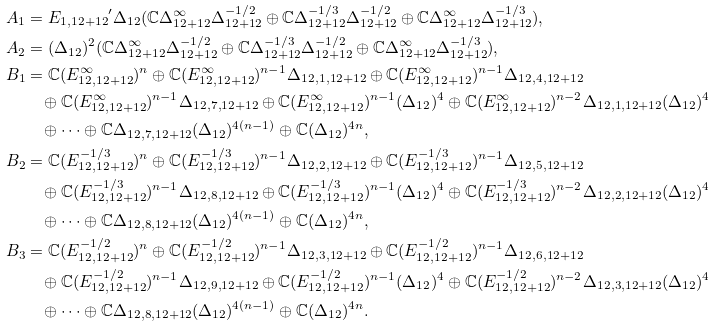<formula> <loc_0><loc_0><loc_500><loc_500>A _ { 1 } & = { E _ { 1 , 1 2 + 1 2 } } ^ { \prime } \Delta _ { 1 2 } ( \mathbb { C } \Delta _ { 1 2 + 1 2 } ^ { \infty } \Delta _ { 1 2 + 1 2 } ^ { - 1 / 2 } \oplus \mathbb { C } \Delta _ { 1 2 + 1 2 } ^ { - 1 / 3 } \Delta _ { 1 2 + 1 2 } ^ { - 1 / 2 } \oplus \mathbb { C } \Delta _ { 1 2 + 1 2 } ^ { \infty } \Delta _ { 1 2 + 1 2 } ^ { - 1 / 3 } ) , \\ A _ { 2 } & = ( \Delta _ { 1 2 } ) ^ { 2 } ( \mathbb { C } \Delta _ { 1 2 + 1 2 } ^ { \infty } \Delta _ { 1 2 + 1 2 } ^ { - 1 / 2 } \oplus \mathbb { C } \Delta _ { 1 2 + 1 2 } ^ { - 1 / 3 } \Delta _ { 1 2 + 1 2 } ^ { - 1 / 2 } \oplus \mathbb { C } \Delta _ { 1 2 + 1 2 } ^ { \infty } \Delta _ { 1 2 + 1 2 } ^ { - 1 / 3 } ) , \\ B _ { 1 } & = \mathbb { C } ( E _ { 1 2 , 1 2 + 1 2 } ^ { \infty } ) ^ { n } \oplus \mathbb { C } ( E _ { 1 2 , 1 2 + 1 2 } ^ { \infty } ) ^ { n - 1 } \Delta _ { 1 2 , 1 , 1 2 + 1 2 } \oplus \mathbb { C } ( E _ { 1 2 , 1 2 + 1 2 } ^ { \infty } ) ^ { n - 1 } \Delta _ { 1 2 , 4 , 1 2 + 1 2 } \\ & \quad \oplus \mathbb { C } ( E _ { 1 2 , 1 2 + 1 2 } ^ { \infty } ) ^ { n - 1 } \Delta _ { 1 2 , 7 , 1 2 + 1 2 } \oplus \mathbb { C } ( E _ { 1 2 , 1 2 + 1 2 } ^ { \infty } ) ^ { n - 1 } ( \Delta _ { 1 2 } ) ^ { 4 } \oplus \mathbb { C } ( E _ { 1 2 , 1 2 + 1 2 } ^ { \infty } ) ^ { n - 2 } \Delta _ { 1 2 , 1 , 1 2 + 1 2 } ( \Delta _ { 1 2 } ) ^ { 4 } \\ & \quad \oplus \cdots \oplus \mathbb { C } \Delta _ { 1 2 , 7 , 1 2 + 1 2 } ( \Delta _ { 1 2 } ) ^ { 4 ( n - 1 ) } \oplus \mathbb { C } ( \Delta _ { 1 2 } ) ^ { 4 n } , \\ B _ { 2 } & = \mathbb { C } ( E _ { 1 2 , 1 2 + 1 2 } ^ { - 1 / 3 } ) ^ { n } \oplus \mathbb { C } ( E _ { 1 2 , 1 2 + 1 2 } ^ { - 1 / 3 } ) ^ { n - 1 } \Delta _ { 1 2 , 2 , 1 2 + 1 2 } \oplus \mathbb { C } ( E _ { 1 2 , 1 2 + 1 2 } ^ { - 1 / 3 } ) ^ { n - 1 } \Delta _ { 1 2 , 5 , 1 2 + 1 2 } \\ & \quad \oplus \mathbb { C } ( E _ { 1 2 , 1 2 + 1 2 } ^ { - 1 / 3 } ) ^ { n - 1 } \Delta _ { 1 2 , 8 , 1 2 + 1 2 } \oplus \mathbb { C } ( E _ { 1 2 , 1 2 + 1 2 } ^ { - 1 / 3 } ) ^ { n - 1 } ( \Delta _ { 1 2 } ) ^ { 4 } \oplus \mathbb { C } ( E _ { 1 2 , 1 2 + 1 2 } ^ { - 1 / 3 } ) ^ { n - 2 } \Delta _ { 1 2 , 2 , 1 2 + 1 2 } ( \Delta _ { 1 2 } ) ^ { 4 } \\ & \quad \oplus \cdots \oplus \mathbb { C } \Delta _ { 1 2 , 8 , 1 2 + 1 2 } ( \Delta _ { 1 2 } ) ^ { 4 ( n - 1 ) } \oplus \mathbb { C } ( \Delta _ { 1 2 } ) ^ { 4 n } , \\ B _ { 3 } & = \mathbb { C } ( E _ { 1 2 , 1 2 + 1 2 } ^ { - 1 / 2 } ) ^ { n } \oplus \mathbb { C } ( E _ { 1 2 , 1 2 + 1 2 } ^ { - 1 / 2 } ) ^ { n - 1 } \Delta _ { 1 2 , 3 , 1 2 + 1 2 } \oplus \mathbb { C } ( E _ { 1 2 , 1 2 + 1 2 } ^ { - 1 / 2 } ) ^ { n - 1 } \Delta _ { 1 2 , 6 , 1 2 + 1 2 } \\ & \quad \oplus \mathbb { C } ( E _ { 1 2 , 1 2 + 1 2 } ^ { - 1 / 2 } ) ^ { n - 1 } \Delta _ { 1 2 , 9 , 1 2 + 1 2 } \oplus \mathbb { C } ( E _ { 1 2 , 1 2 + 1 2 } ^ { - 1 / 2 } ) ^ { n - 1 } ( \Delta _ { 1 2 } ) ^ { 4 } \oplus \mathbb { C } ( E _ { 1 2 , 1 2 + 1 2 } ^ { - 1 / 2 } ) ^ { n - 2 } \Delta _ { 1 2 , 3 , 1 2 + 1 2 } ( \Delta _ { 1 2 } ) ^ { 4 } \\ & \quad \oplus \cdots \oplus \mathbb { C } \Delta _ { 1 2 , 8 , 1 2 + 1 2 } ( \Delta _ { 1 2 } ) ^ { 4 ( n - 1 ) } \oplus \mathbb { C } ( \Delta _ { 1 2 } ) ^ { 4 n } .</formula> 